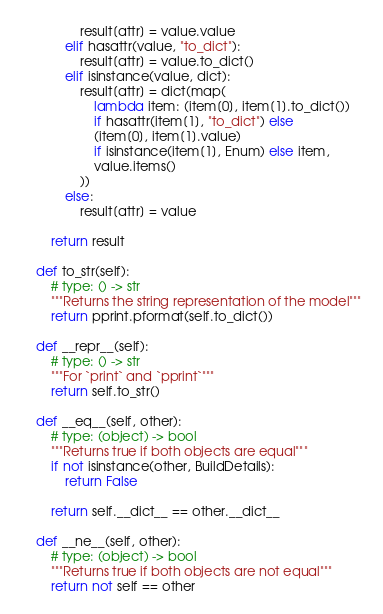Convert code to text. <code><loc_0><loc_0><loc_500><loc_500><_Python_>                result[attr] = value.value
            elif hasattr(value, "to_dict"):
                result[attr] = value.to_dict()
            elif isinstance(value, dict):
                result[attr] = dict(map(
                    lambda item: (item[0], item[1].to_dict())
                    if hasattr(item[1], "to_dict") else
                    (item[0], item[1].value)
                    if isinstance(item[1], Enum) else item,
                    value.items()
                ))
            else:
                result[attr] = value

        return result

    def to_str(self):
        # type: () -> str
        """Returns the string representation of the model"""
        return pprint.pformat(self.to_dict())

    def __repr__(self):
        # type: () -> str
        """For `print` and `pprint`"""
        return self.to_str()

    def __eq__(self, other):
        # type: (object) -> bool
        """Returns true if both objects are equal"""
        if not isinstance(other, BuildDetails):
            return False

        return self.__dict__ == other.__dict__

    def __ne__(self, other):
        # type: (object) -> bool
        """Returns true if both objects are not equal"""
        return not self == other
</code> 